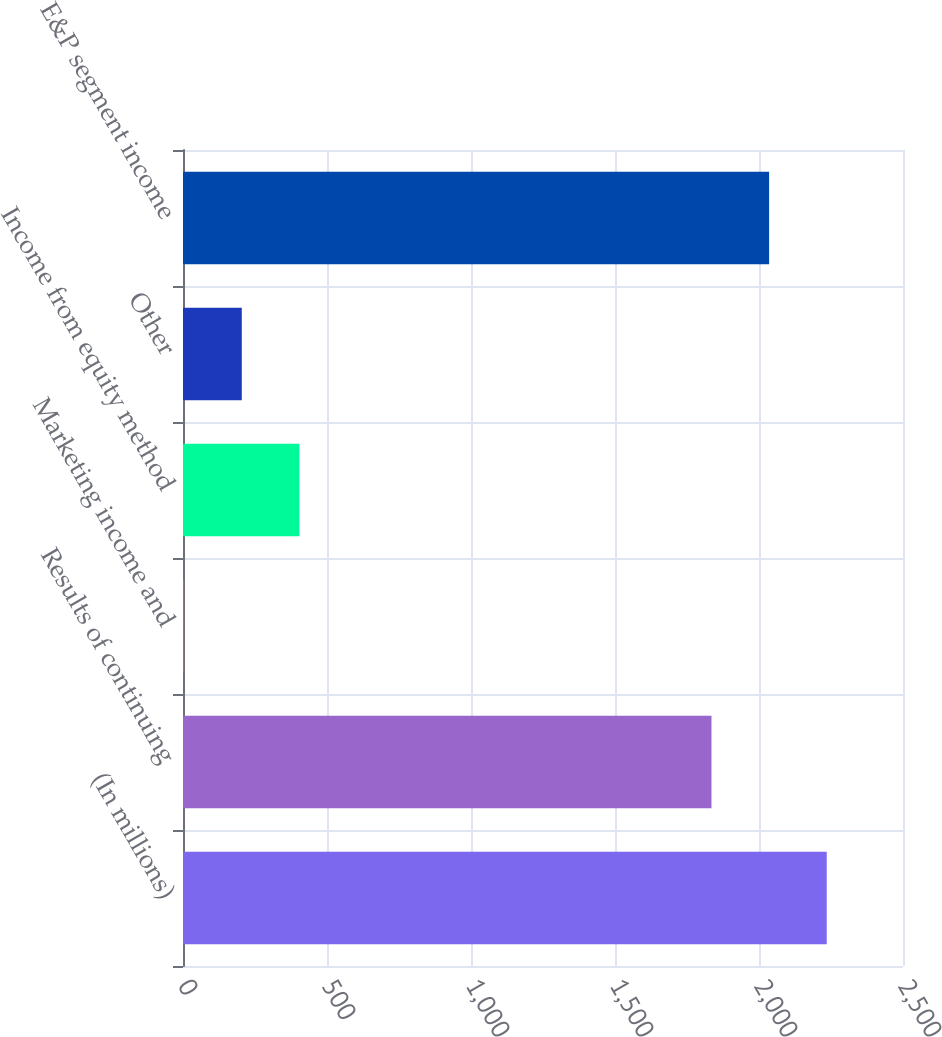<chart> <loc_0><loc_0><loc_500><loc_500><bar_chart><fcel>(In millions)<fcel>Results of continuing<fcel>Marketing income and<fcel>Income from equity method<fcel>Other<fcel>E&P segment income<nl><fcel>2235.2<fcel>1835<fcel>4<fcel>404.2<fcel>204.1<fcel>2035.1<nl></chart> 